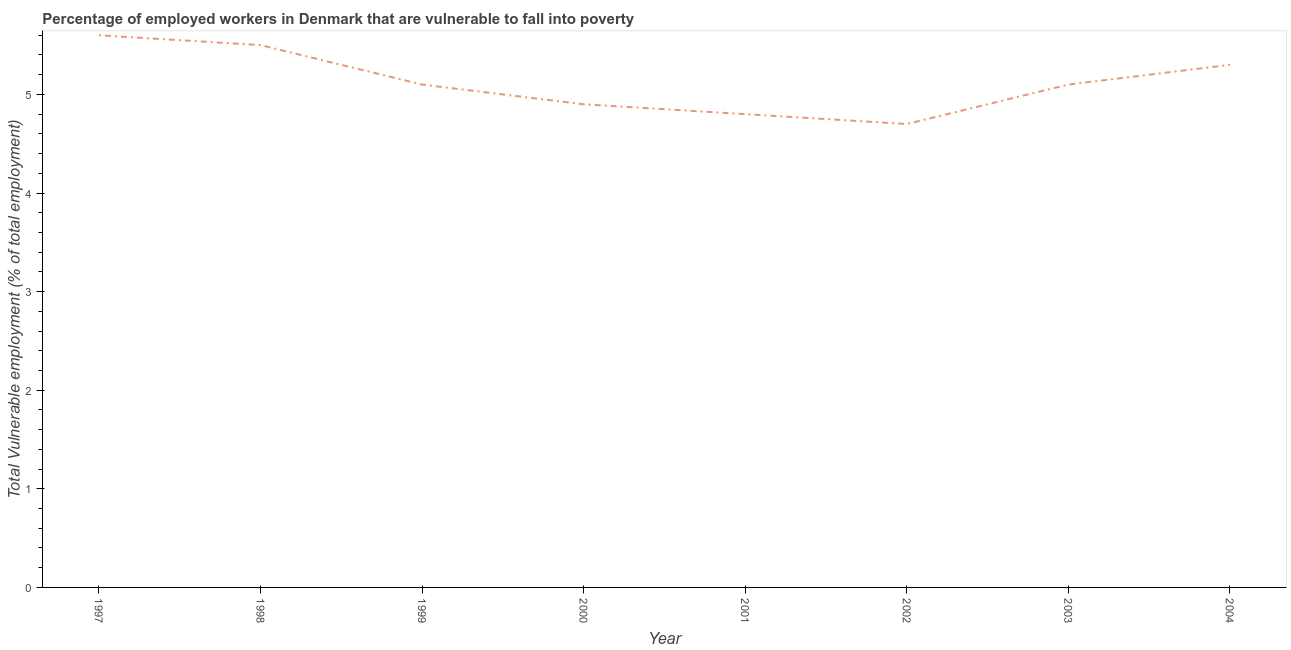What is the total vulnerable employment in 1999?
Your answer should be very brief. 5.1. Across all years, what is the maximum total vulnerable employment?
Your answer should be compact. 5.6. Across all years, what is the minimum total vulnerable employment?
Your answer should be very brief. 4.7. What is the sum of the total vulnerable employment?
Your response must be concise. 41. What is the difference between the total vulnerable employment in 1997 and 2001?
Offer a terse response. 0.8. What is the average total vulnerable employment per year?
Keep it short and to the point. 5.12. What is the median total vulnerable employment?
Provide a succinct answer. 5.1. What is the ratio of the total vulnerable employment in 2002 to that in 2004?
Provide a succinct answer. 0.89. Is the total vulnerable employment in 1997 less than that in 1998?
Your answer should be very brief. No. What is the difference between the highest and the second highest total vulnerable employment?
Your answer should be very brief. 0.1. What is the difference between the highest and the lowest total vulnerable employment?
Ensure brevity in your answer.  0.9. What is the difference between two consecutive major ticks on the Y-axis?
Keep it short and to the point. 1. Does the graph contain any zero values?
Provide a short and direct response. No. What is the title of the graph?
Offer a terse response. Percentage of employed workers in Denmark that are vulnerable to fall into poverty. What is the label or title of the Y-axis?
Your response must be concise. Total Vulnerable employment (% of total employment). What is the Total Vulnerable employment (% of total employment) in 1997?
Give a very brief answer. 5.6. What is the Total Vulnerable employment (% of total employment) of 1998?
Provide a succinct answer. 5.5. What is the Total Vulnerable employment (% of total employment) of 1999?
Ensure brevity in your answer.  5.1. What is the Total Vulnerable employment (% of total employment) of 2000?
Provide a succinct answer. 4.9. What is the Total Vulnerable employment (% of total employment) in 2001?
Your answer should be very brief. 4.8. What is the Total Vulnerable employment (% of total employment) of 2002?
Provide a short and direct response. 4.7. What is the Total Vulnerable employment (% of total employment) of 2003?
Your response must be concise. 5.1. What is the Total Vulnerable employment (% of total employment) in 2004?
Your answer should be very brief. 5.3. What is the difference between the Total Vulnerable employment (% of total employment) in 1997 and 1999?
Your response must be concise. 0.5. What is the difference between the Total Vulnerable employment (% of total employment) in 1997 and 2001?
Offer a very short reply. 0.8. What is the difference between the Total Vulnerable employment (% of total employment) in 1997 and 2002?
Your answer should be compact. 0.9. What is the difference between the Total Vulnerable employment (% of total employment) in 1997 and 2003?
Offer a very short reply. 0.5. What is the difference between the Total Vulnerable employment (% of total employment) in 1998 and 2000?
Your answer should be very brief. 0.6. What is the difference between the Total Vulnerable employment (% of total employment) in 1998 and 2003?
Your answer should be very brief. 0.4. What is the difference between the Total Vulnerable employment (% of total employment) in 1999 and 2001?
Offer a very short reply. 0.3. What is the difference between the Total Vulnerable employment (% of total employment) in 1999 and 2002?
Make the answer very short. 0.4. What is the difference between the Total Vulnerable employment (% of total employment) in 1999 and 2003?
Offer a terse response. 0. What is the difference between the Total Vulnerable employment (% of total employment) in 1999 and 2004?
Offer a very short reply. -0.2. What is the difference between the Total Vulnerable employment (% of total employment) in 2000 and 2002?
Your response must be concise. 0.2. What is the difference between the Total Vulnerable employment (% of total employment) in 2001 and 2003?
Provide a succinct answer. -0.3. What is the difference between the Total Vulnerable employment (% of total employment) in 2001 and 2004?
Your answer should be compact. -0.5. What is the ratio of the Total Vulnerable employment (% of total employment) in 1997 to that in 1998?
Your answer should be very brief. 1.02. What is the ratio of the Total Vulnerable employment (% of total employment) in 1997 to that in 1999?
Ensure brevity in your answer.  1.1. What is the ratio of the Total Vulnerable employment (% of total employment) in 1997 to that in 2000?
Ensure brevity in your answer.  1.14. What is the ratio of the Total Vulnerable employment (% of total employment) in 1997 to that in 2001?
Offer a terse response. 1.17. What is the ratio of the Total Vulnerable employment (% of total employment) in 1997 to that in 2002?
Offer a very short reply. 1.19. What is the ratio of the Total Vulnerable employment (% of total employment) in 1997 to that in 2003?
Your response must be concise. 1.1. What is the ratio of the Total Vulnerable employment (% of total employment) in 1997 to that in 2004?
Offer a terse response. 1.06. What is the ratio of the Total Vulnerable employment (% of total employment) in 1998 to that in 1999?
Ensure brevity in your answer.  1.08. What is the ratio of the Total Vulnerable employment (% of total employment) in 1998 to that in 2000?
Provide a short and direct response. 1.12. What is the ratio of the Total Vulnerable employment (% of total employment) in 1998 to that in 2001?
Your answer should be very brief. 1.15. What is the ratio of the Total Vulnerable employment (% of total employment) in 1998 to that in 2002?
Offer a terse response. 1.17. What is the ratio of the Total Vulnerable employment (% of total employment) in 1998 to that in 2003?
Provide a succinct answer. 1.08. What is the ratio of the Total Vulnerable employment (% of total employment) in 1998 to that in 2004?
Your answer should be very brief. 1.04. What is the ratio of the Total Vulnerable employment (% of total employment) in 1999 to that in 2000?
Your response must be concise. 1.04. What is the ratio of the Total Vulnerable employment (% of total employment) in 1999 to that in 2001?
Your response must be concise. 1.06. What is the ratio of the Total Vulnerable employment (% of total employment) in 1999 to that in 2002?
Your response must be concise. 1.08. What is the ratio of the Total Vulnerable employment (% of total employment) in 1999 to that in 2004?
Provide a short and direct response. 0.96. What is the ratio of the Total Vulnerable employment (% of total employment) in 2000 to that in 2001?
Your answer should be very brief. 1.02. What is the ratio of the Total Vulnerable employment (% of total employment) in 2000 to that in 2002?
Your response must be concise. 1.04. What is the ratio of the Total Vulnerable employment (% of total employment) in 2000 to that in 2004?
Your answer should be compact. 0.93. What is the ratio of the Total Vulnerable employment (% of total employment) in 2001 to that in 2002?
Offer a very short reply. 1.02. What is the ratio of the Total Vulnerable employment (% of total employment) in 2001 to that in 2003?
Offer a very short reply. 0.94. What is the ratio of the Total Vulnerable employment (% of total employment) in 2001 to that in 2004?
Your response must be concise. 0.91. What is the ratio of the Total Vulnerable employment (% of total employment) in 2002 to that in 2003?
Provide a succinct answer. 0.92. What is the ratio of the Total Vulnerable employment (% of total employment) in 2002 to that in 2004?
Give a very brief answer. 0.89. 